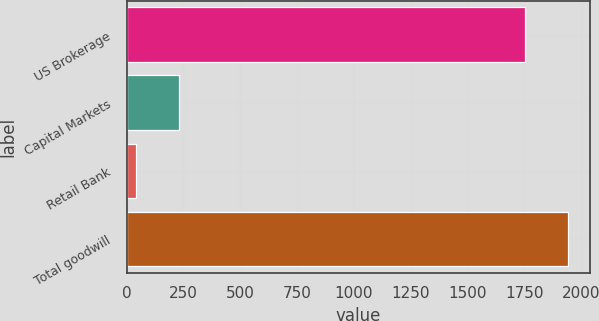<chart> <loc_0><loc_0><loc_500><loc_500><bar_chart><fcel>US Brokerage<fcel>Capital Markets<fcel>Retail Bank<fcel>Total goodwill<nl><fcel>1751.2<fcel>229.96<fcel>40.6<fcel>1940.56<nl></chart> 